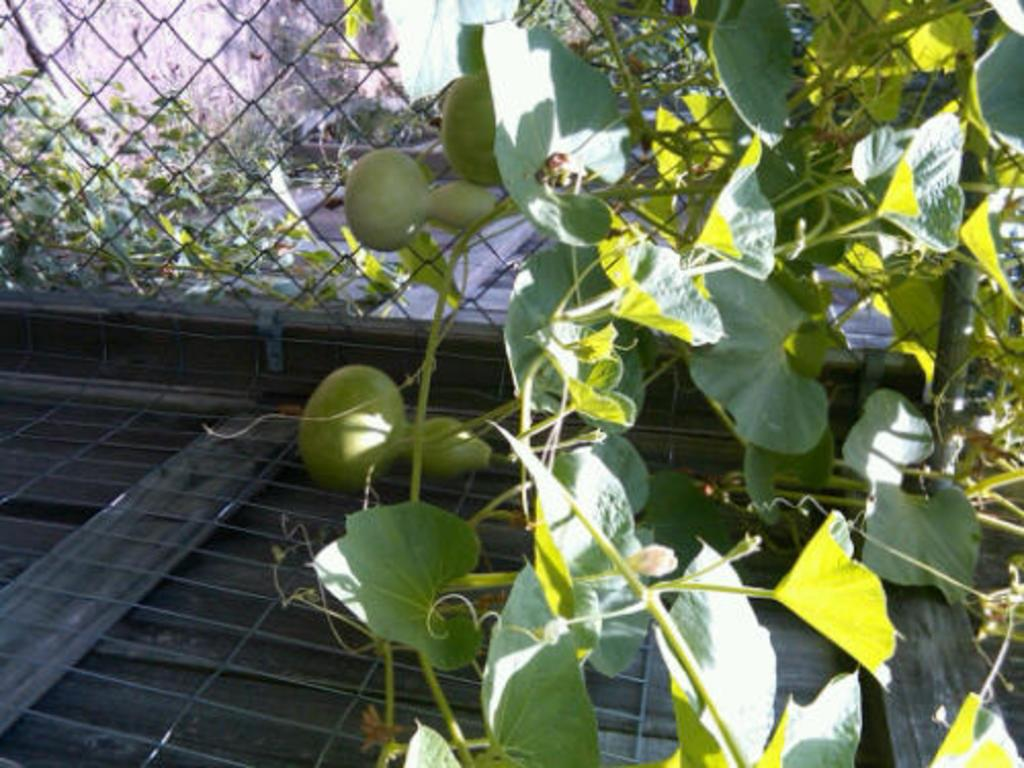What type of plant can be seen on the right side of the image? There is a creeper with leaves and fruits on the right side of the image. What is located on the left side of the image? There is a fencing on the left side of the image. What can be seen behind the fencing? There are leaves behind the fencing. Where is the most valuable jewel in the image? There is no jewel present in the image. How does the creeper stretch across the image? The creeper does not stretch in the image; it is stationary with leaves and fruits on the right side. 